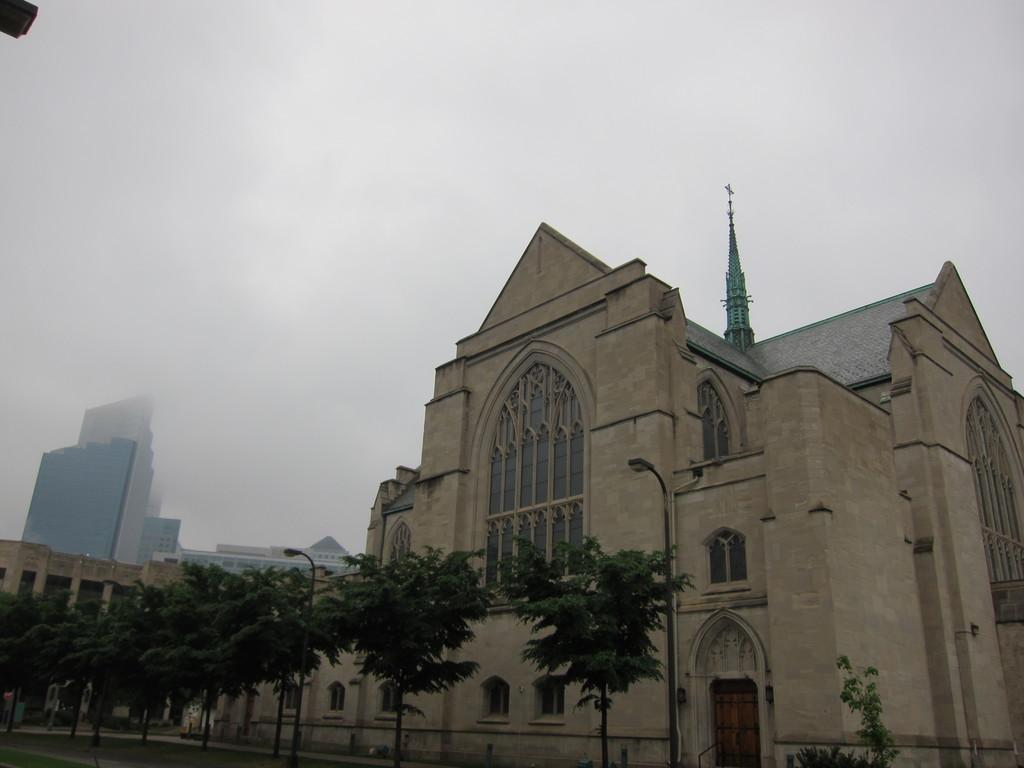What type of structure is visible in the image? There is a building in the image. What can be seen at the bottom of the image? Poles, street lights, trees, and grass are visible at the bottom of the image. Are there any other buildings in the image? Yes, there are buildings in the background of the image. What is the condition of the sky in the image? The sky is cloudy at the top of the image. What degree of difficulty is the wing shown in the image? There is no wing present in the image, so it is not possible to determine its degree of difficulty. 